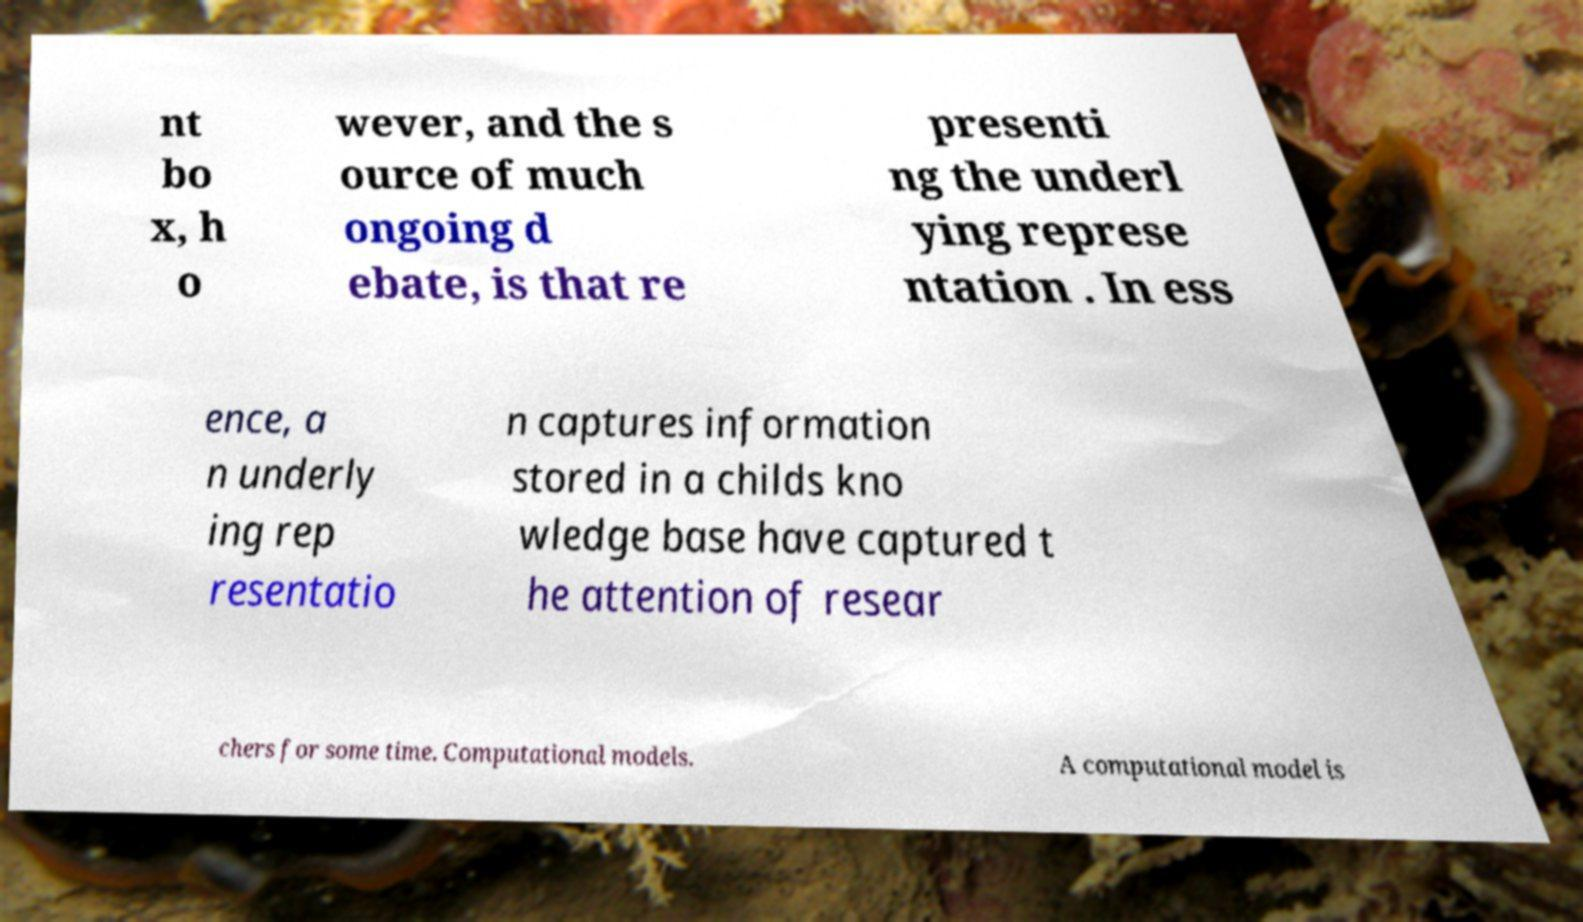There's text embedded in this image that I need extracted. Can you transcribe it verbatim? nt bo x, h o wever, and the s ource of much ongoing d ebate, is that re presenti ng the underl ying represe ntation . In ess ence, a n underly ing rep resentatio n captures information stored in a childs kno wledge base have captured t he attention of resear chers for some time. Computational models. A computational model is 